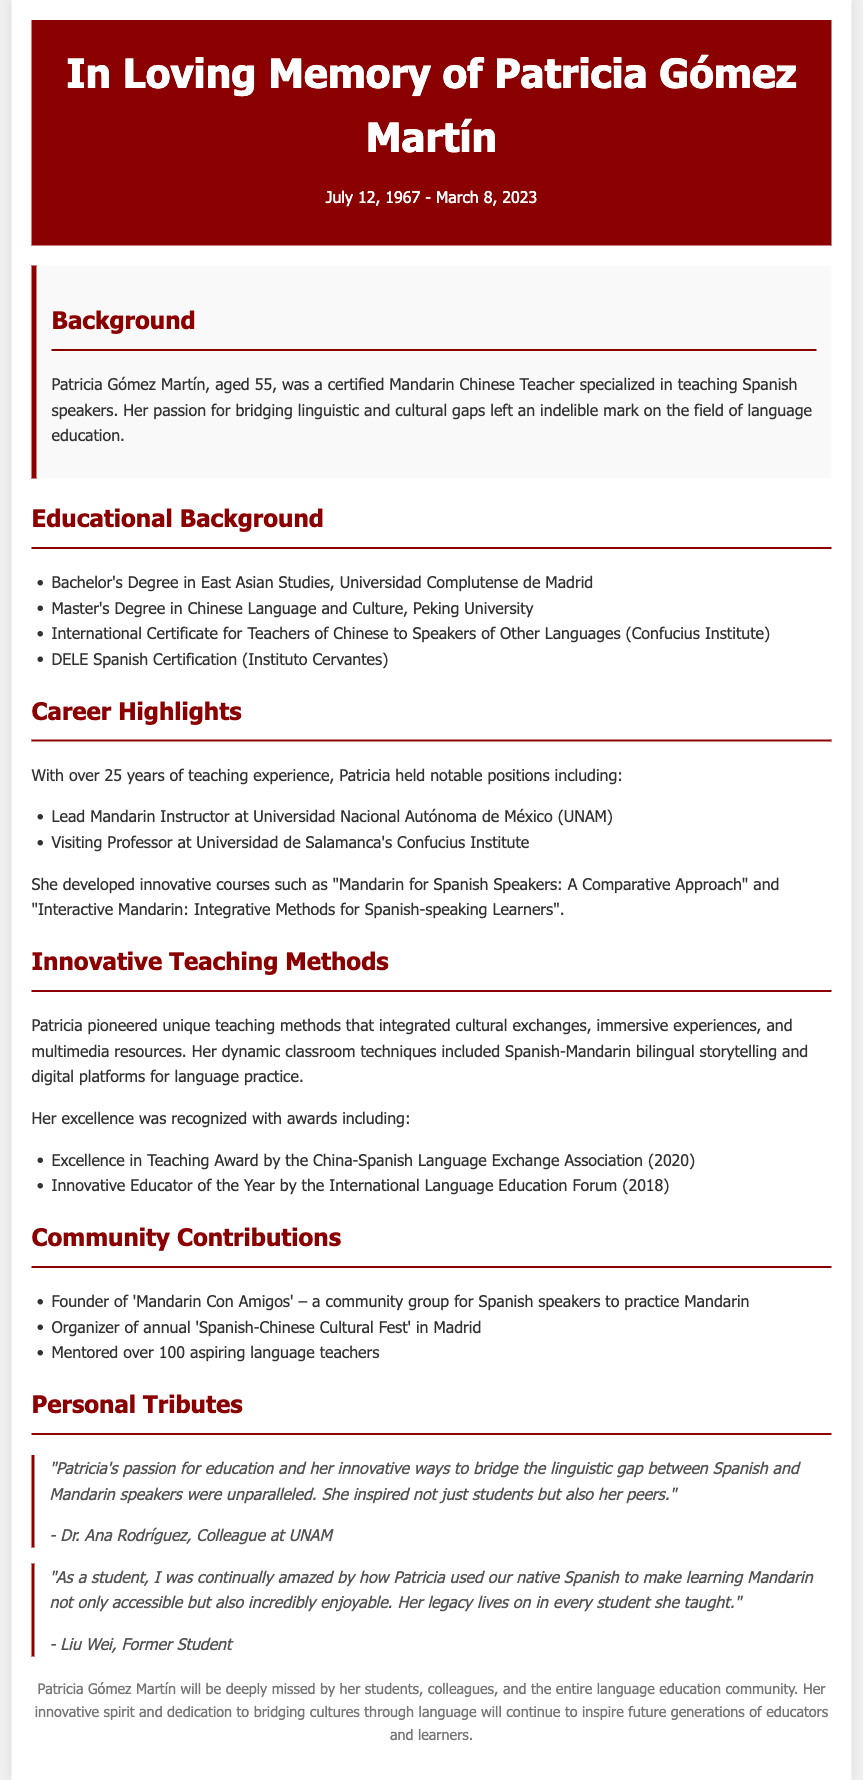What was the date of Patricia Gómez Martín's passing? The date of passing is directly stated in the header of the document.
Answer: March 8, 2023 Where did Patricia complete her Master's Degree? The educational background section lists her Master's Degree in Chinese Language and Culture from a specific university.
Answer: Peking University What innovative course did Patricia develop? The career highlights mention specific courses that she created, making it a relevant question.
Answer: Mandarin for Spanish Speakers: A Comparative Approach Which award did Patricia receive in 2020? The methods section lists awards she received, and the year is specified for one of them.
Answer: Excellence in Teaching Award What community group did Patricia found? The community contributions section specifies a group closely related to her work.
Answer: Mandarin Con Amigos How many years of teaching experience did Patricia have? The career highlights section provides the duration of her teaching experience.
Answer: Over 25 years What is one of the personal tributes about Patricia? The personal tributes section contains quotes about her impact, showcasing her teaching style and influence.
Answer: "Patricia's passion for education and her innovative ways to bridge the linguistic gap between Spanish and Mandarin speakers were unparalleled." What does the footer say about Patricia’s legacy? The footer summarizes the overall impact of Patricia on her community and future generations, focusing on her spirit and dedication.
Answer: Her innovative spirit and dedication to bridging cultures through language will continue to inspire future generations of educators and learners 